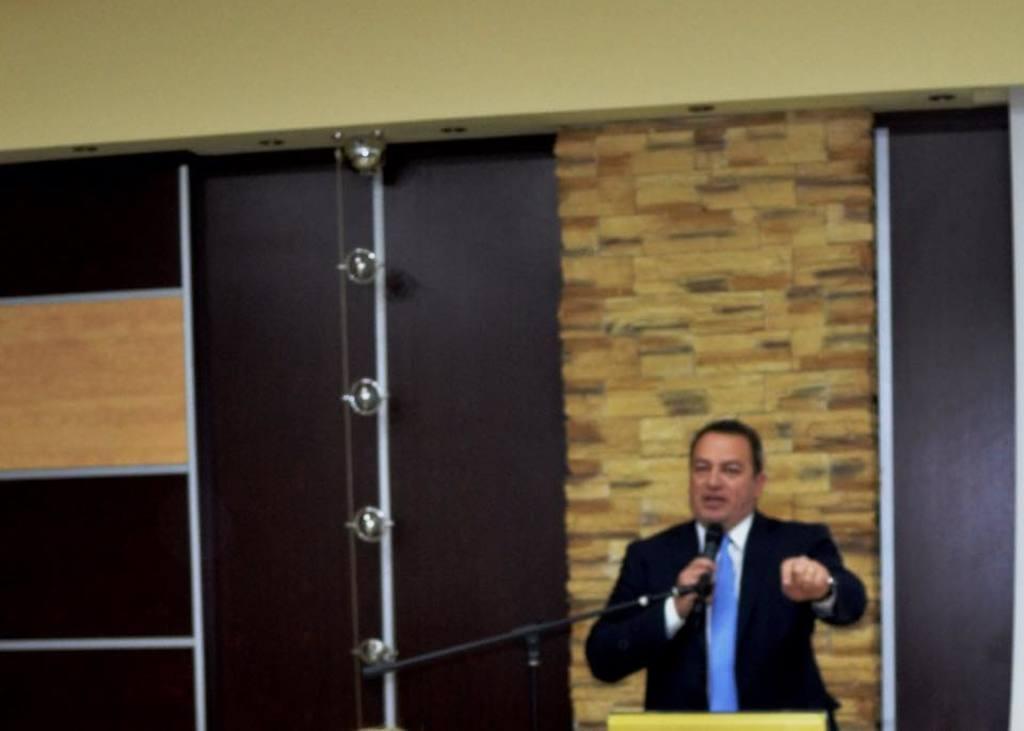Can you describe this image briefly? At the bottom there is a man wearing a suit, standing, holding a mike in the hand and speaking. At the back of him there are few wooden planks which seems to be cupboards. Beside him there is a metal stand with dome lights. At the top of the image there is a wall. 